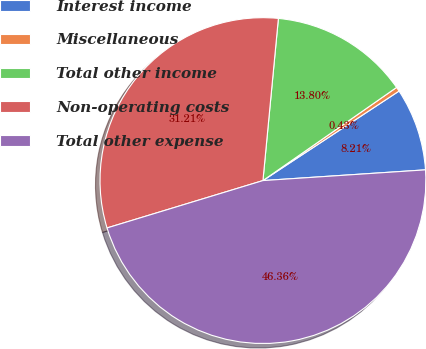Convert chart to OTSL. <chart><loc_0><loc_0><loc_500><loc_500><pie_chart><fcel>Interest income<fcel>Miscellaneous<fcel>Total other income<fcel>Non-operating costs<fcel>Total other expense<nl><fcel>8.21%<fcel>0.43%<fcel>13.8%<fcel>31.21%<fcel>46.36%<nl></chart> 